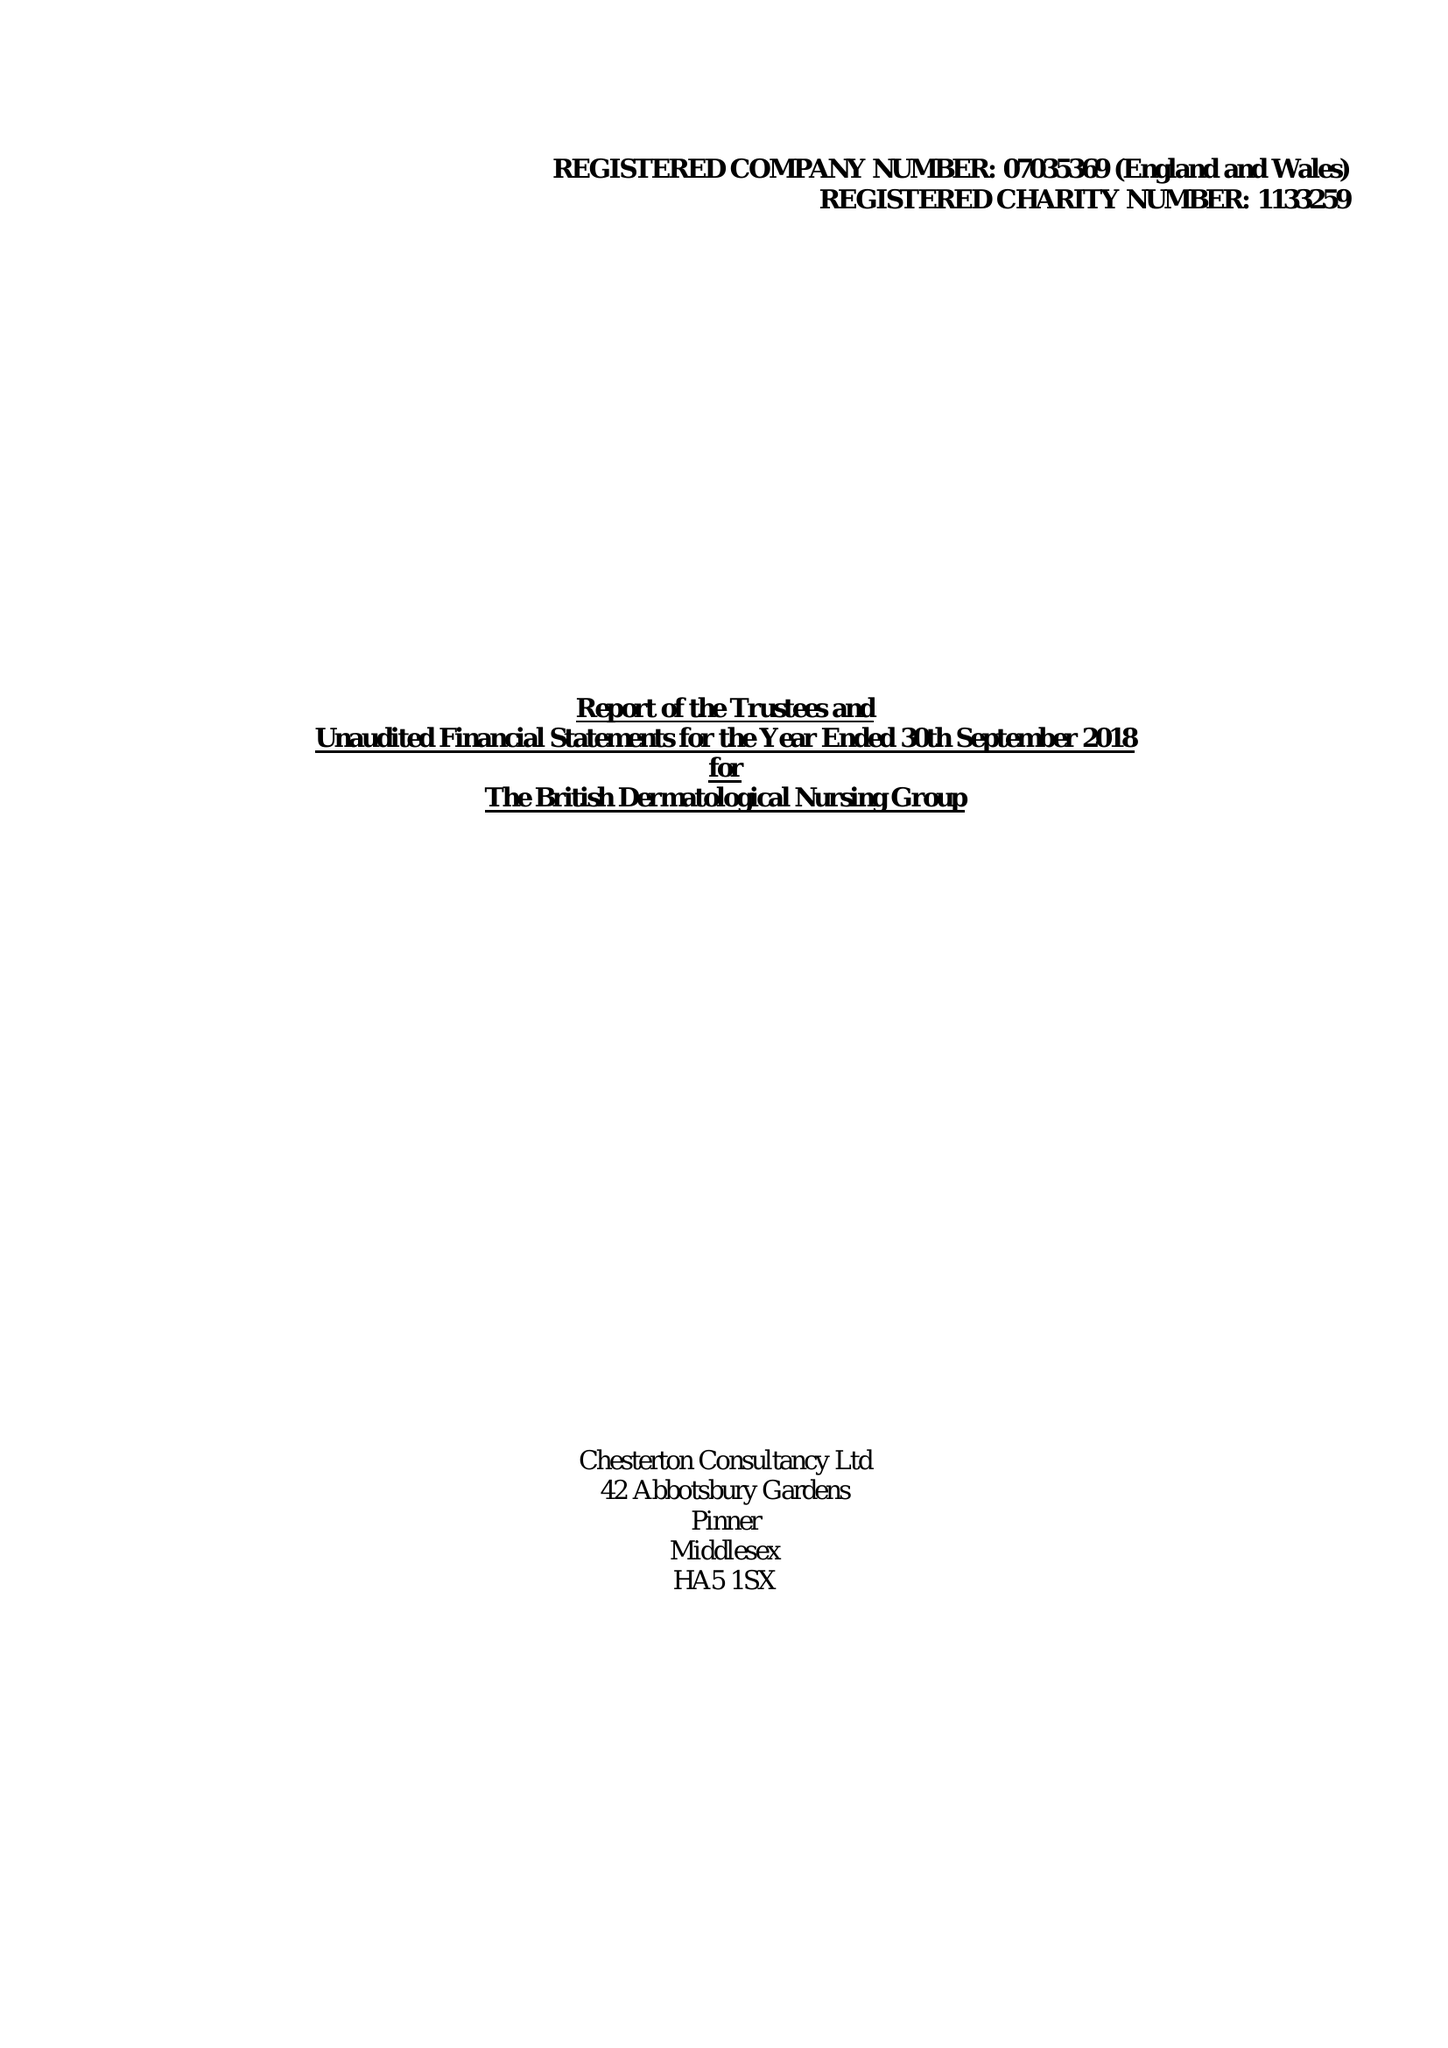What is the value for the report_date?
Answer the question using a single word or phrase. 2018-09-30 